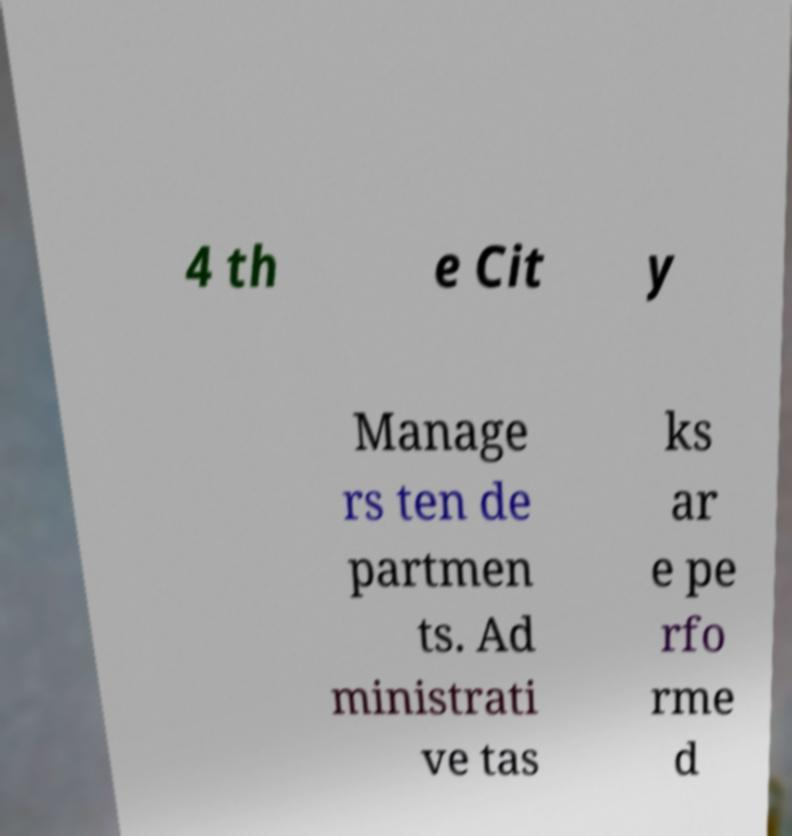What messages or text are displayed in this image? I need them in a readable, typed format. 4 th e Cit y Manage rs ten de partmen ts. Ad ministrati ve tas ks ar e pe rfo rme d 